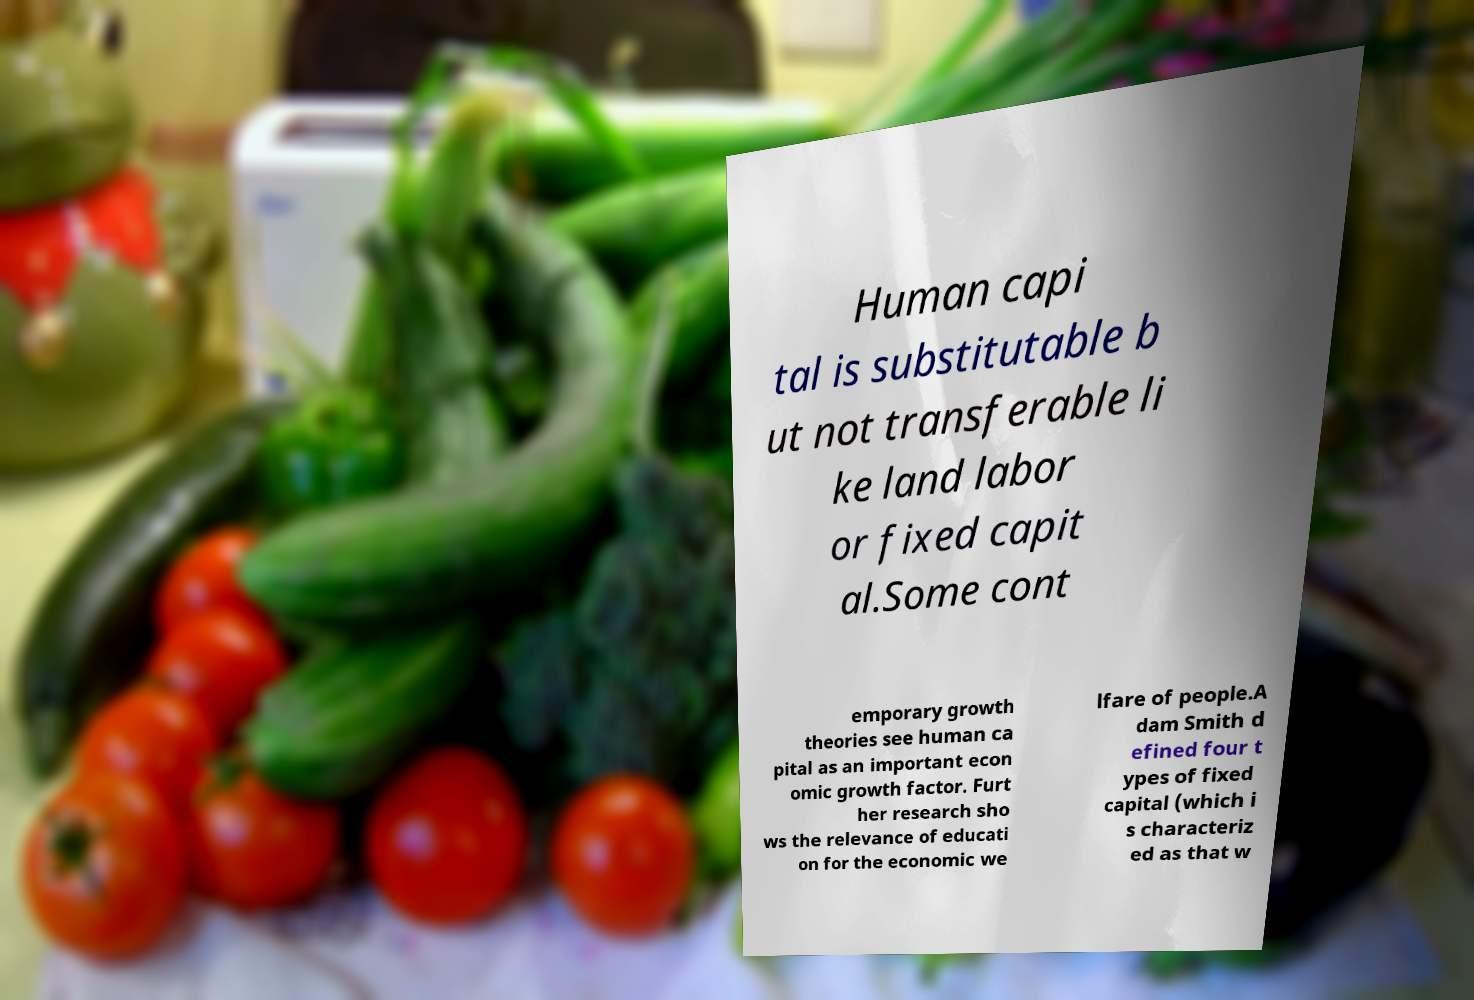What messages or text are displayed in this image? I need them in a readable, typed format. Human capi tal is substitutable b ut not transferable li ke land labor or fixed capit al.Some cont emporary growth theories see human ca pital as an important econ omic growth factor. Furt her research sho ws the relevance of educati on for the economic we lfare of people.A dam Smith d efined four t ypes of fixed capital (which i s characteriz ed as that w 